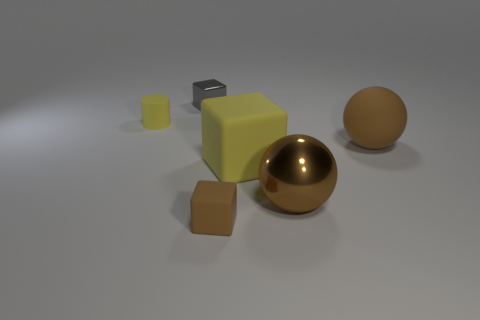Add 1 big cubes. How many objects exist? 7 Subtract all cylinders. How many objects are left? 5 Subtract all tiny purple cylinders. Subtract all small yellow rubber cylinders. How many objects are left? 5 Add 3 spheres. How many spheres are left? 5 Add 4 brown balls. How many brown balls exist? 6 Subtract 0 cyan cylinders. How many objects are left? 6 